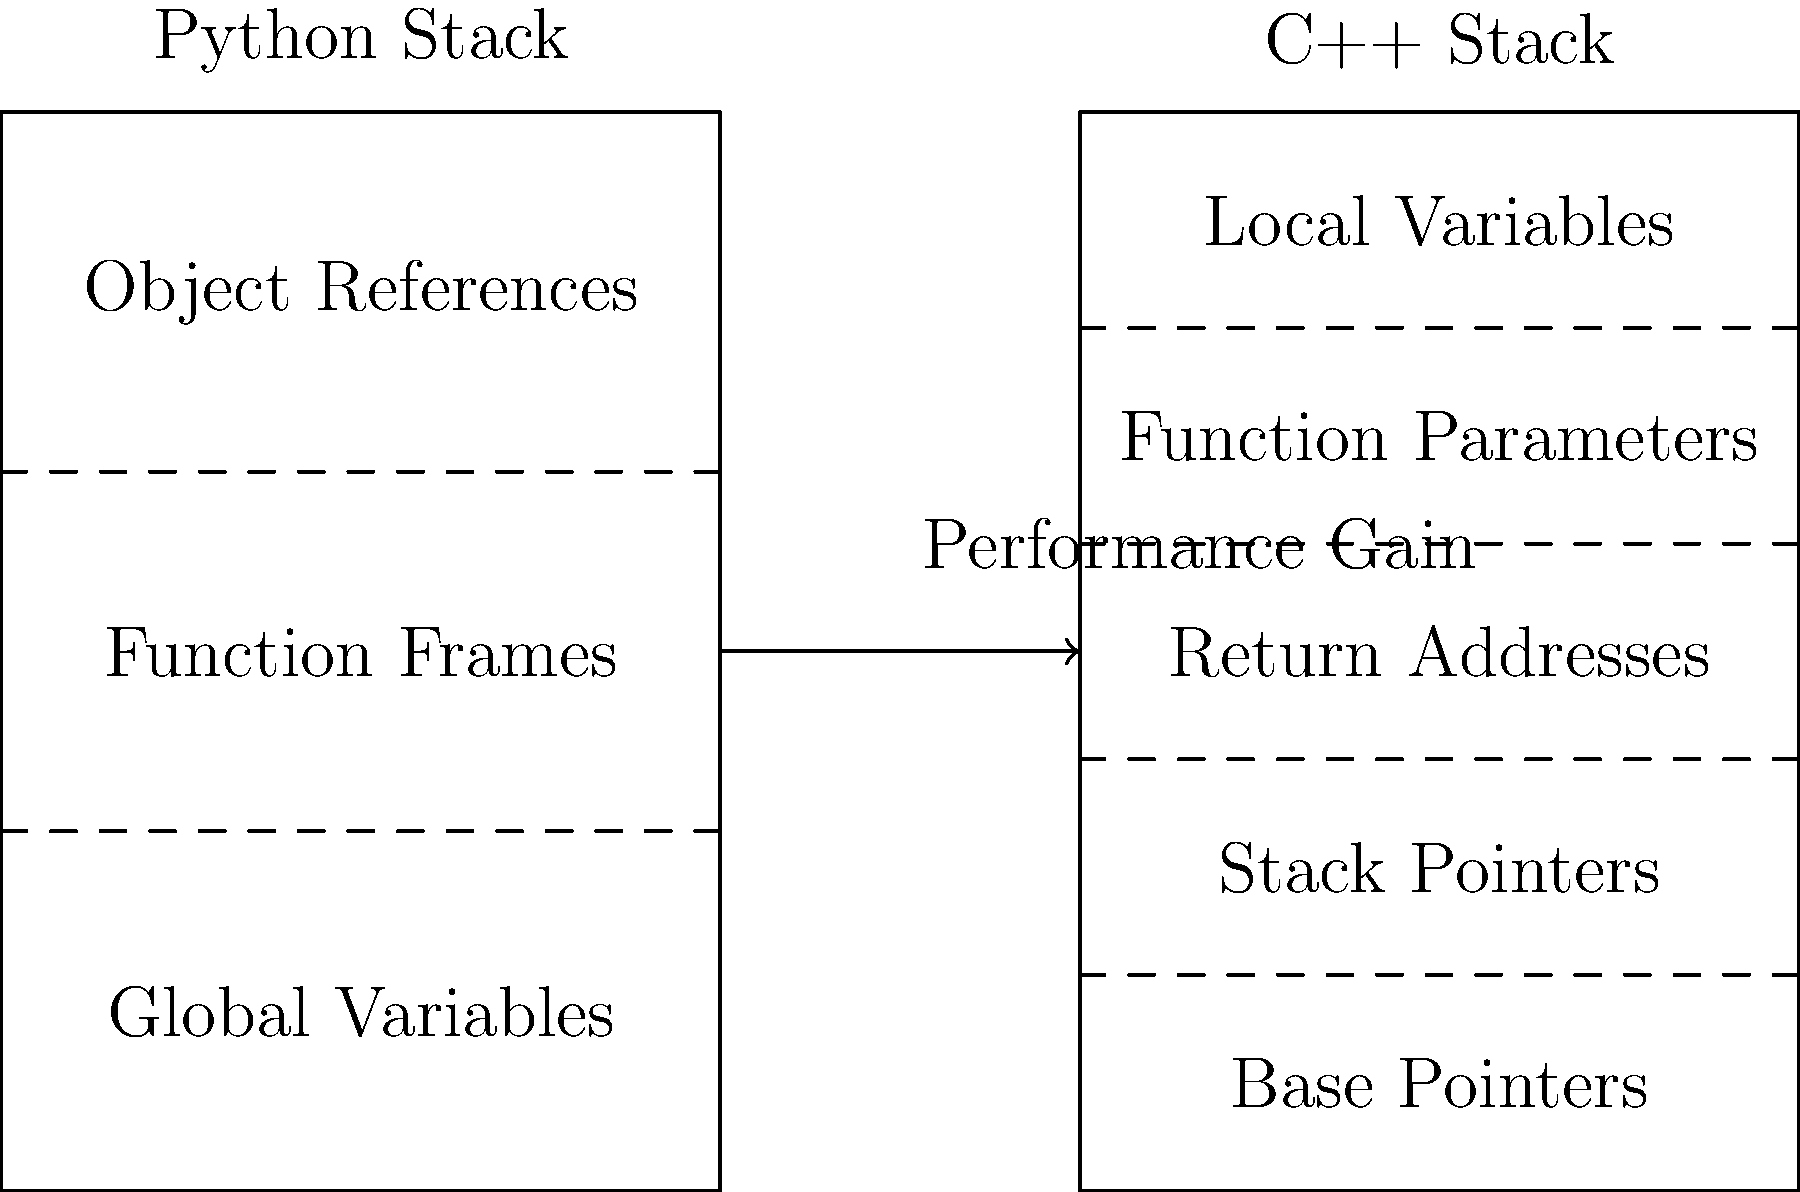Based on the stack diagrams for Python and C++, which aspect of C++'s memory management contributes most significantly to its performance advantage over Python when integrating C++ modules into a Python project? To understand the performance advantage of C++ over Python, let's analyze the stack diagrams:

1. Python Stack:
   - Object References: Python uses reference counting for memory management.
   - Function Frames: Contains local variables and execution context.
   - Global Variables: Stored in a separate area.

2. C++ Stack:
   - Local Variables: Directly stored on the stack.
   - Function Parameters: Efficiently passed on the stack.
   - Return Addresses: For function call management.
   - Stack Pointers: Manage the top of the stack.
   - Base Pointers: Reference for accessing local variables and parameters.

3. Key Differences:
   a. Direct Memory Access: C++ stores local variables directly on the stack, allowing for faster access.
   b. Static Typing: C++ variables have predetermined sizes, enabling more efficient memory allocation.
   c. No Reference Counting: C++ doesn't use reference counting, reducing overhead.
   d. Manual Memory Management: C++ allows for precise control over memory allocation and deallocation.

4. Performance Impact:
   - The most significant performance gain comes from C++'s direct memory access and static typing.
   - Local variables in C++ are accessed faster due to their stack location and known sizes.
   - This reduces memory lookup times and improves overall execution speed.

5. Integration Benefit:
   - When integrating C++ modules into Python, computationally intensive tasks can leverage this efficient memory management.
   - Operations involving numerous local variables or frequent function calls will see substantial performance improvements.

Therefore, the aspect of C++'s memory management that contributes most significantly to its performance advantage is the direct storage and access of local variables on the stack, facilitated by static typing and efficient stack organization.
Answer: Direct stack storage of local variables 